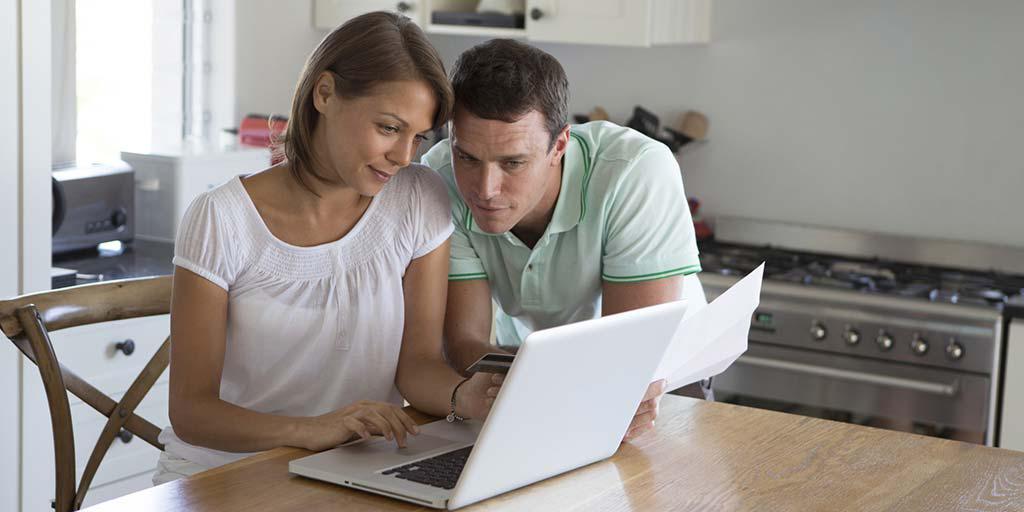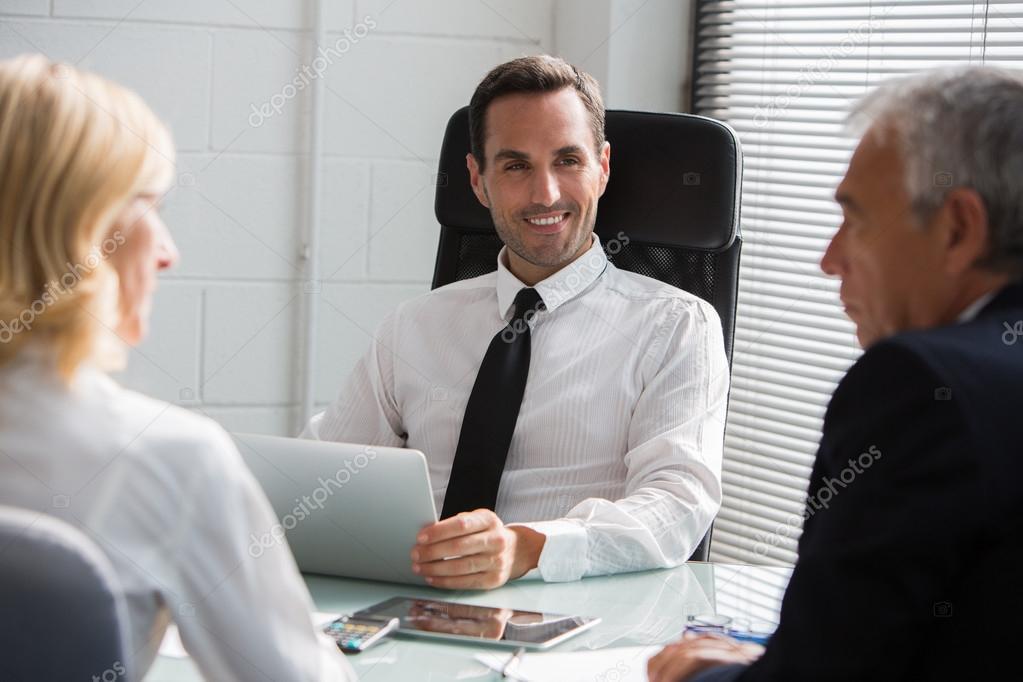The first image is the image on the left, the second image is the image on the right. Considering the images on both sides, is "The right image contains a man wearing a white shirt with a black tie." valid? Answer yes or no. Yes. The first image is the image on the left, the second image is the image on the right. Considering the images on both sides, is "The left image shows a person leaning in to look at an open laptop in front of a different person, and the right image includes a man in a necktie sitting behind a laptop." valid? Answer yes or no. Yes. 